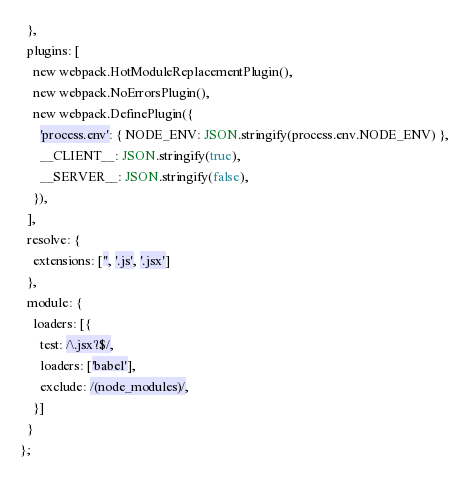<code> <loc_0><loc_0><loc_500><loc_500><_JavaScript_>  },
  plugins: [
    new webpack.HotModuleReplacementPlugin(),
    new webpack.NoErrorsPlugin(),
    new webpack.DefinePlugin({
      'process.env': { NODE_ENV: JSON.stringify(process.env.NODE_ENV) },
      __CLIENT__: JSON.stringify(true),
      __SERVER__: JSON.stringify(false),
    }),
  ],
  resolve: {
    extensions: ['', '.js', '.jsx']
  },
  module: {
    loaders: [{
      test: /\.jsx?$/,
      loaders: ['babel'],
      exclude: /(node_modules)/,
    }]
  }
};
</code> 